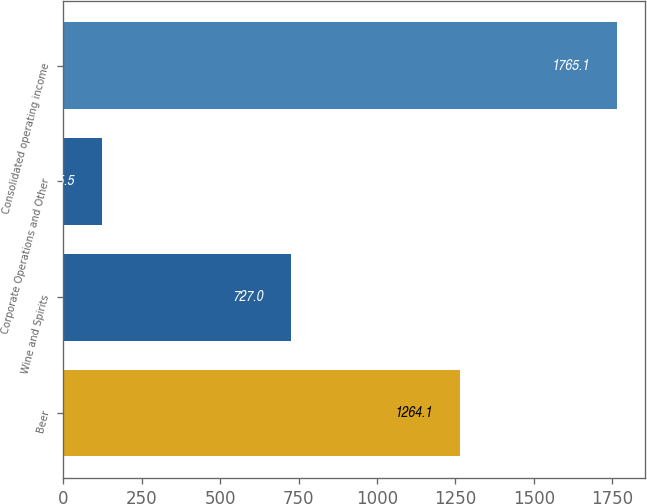<chart> <loc_0><loc_0><loc_500><loc_500><bar_chart><fcel>Beer<fcel>Wine and Spirits<fcel>Corporate Operations and Other<fcel>Consolidated operating income<nl><fcel>1264.1<fcel>727<fcel>125.5<fcel>1765.1<nl></chart> 